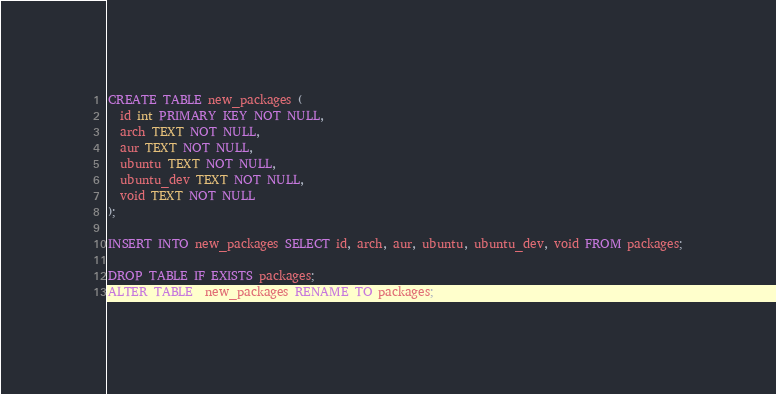<code> <loc_0><loc_0><loc_500><loc_500><_SQL_>CREATE TABLE new_packages (
  id int PRIMARY KEY NOT NULL,
  arch TEXT NOT NULL,
  aur TEXT NOT NULL,
  ubuntu TEXT NOT NULL,
  ubuntu_dev TEXT NOT NULL,
  void TEXT NOT NULL
);

INSERT INTO new_packages SELECT id, arch, aur, ubuntu, ubuntu_dev, void FROM packages;

DROP TABLE IF EXISTS packages;
ALTER TABLE  new_packages RENAME TO packages;
</code> 